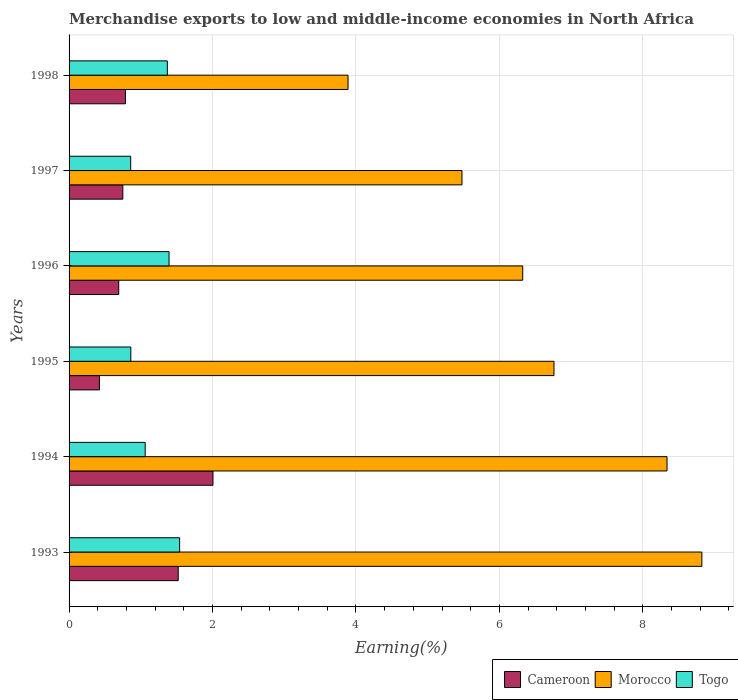How many different coloured bars are there?
Provide a succinct answer. 3. Are the number of bars on each tick of the Y-axis equal?
Your answer should be compact. Yes. How many bars are there on the 3rd tick from the bottom?
Offer a very short reply. 3. In how many cases, is the number of bars for a given year not equal to the number of legend labels?
Make the answer very short. 0. What is the percentage of amount earned from merchandise exports in Morocco in 1996?
Your answer should be very brief. 6.32. Across all years, what is the maximum percentage of amount earned from merchandise exports in Cameroon?
Your answer should be compact. 2.01. Across all years, what is the minimum percentage of amount earned from merchandise exports in Cameroon?
Offer a very short reply. 0.42. In which year was the percentage of amount earned from merchandise exports in Cameroon maximum?
Give a very brief answer. 1994. What is the total percentage of amount earned from merchandise exports in Togo in the graph?
Provide a short and direct response. 7.09. What is the difference between the percentage of amount earned from merchandise exports in Togo in 1993 and that in 1996?
Give a very brief answer. 0.15. What is the difference between the percentage of amount earned from merchandise exports in Morocco in 1997 and the percentage of amount earned from merchandise exports in Togo in 1998?
Provide a short and direct response. 4.11. What is the average percentage of amount earned from merchandise exports in Cameroon per year?
Your answer should be compact. 1.03. In the year 1995, what is the difference between the percentage of amount earned from merchandise exports in Togo and percentage of amount earned from merchandise exports in Cameroon?
Your response must be concise. 0.44. What is the ratio of the percentage of amount earned from merchandise exports in Togo in 1996 to that in 1997?
Provide a succinct answer. 1.62. What is the difference between the highest and the second highest percentage of amount earned from merchandise exports in Cameroon?
Make the answer very short. 0.48. What is the difference between the highest and the lowest percentage of amount earned from merchandise exports in Togo?
Make the answer very short. 0.68. What does the 3rd bar from the top in 1998 represents?
Offer a very short reply. Cameroon. What does the 3rd bar from the bottom in 1993 represents?
Your answer should be compact. Togo. What is the difference between two consecutive major ticks on the X-axis?
Ensure brevity in your answer.  2. Where does the legend appear in the graph?
Ensure brevity in your answer.  Bottom right. What is the title of the graph?
Your response must be concise. Merchandise exports to low and middle-income economies in North Africa. Does "India" appear as one of the legend labels in the graph?
Make the answer very short. No. What is the label or title of the X-axis?
Provide a short and direct response. Earning(%). What is the label or title of the Y-axis?
Your answer should be very brief. Years. What is the Earning(%) of Cameroon in 1993?
Give a very brief answer. 1.52. What is the Earning(%) in Morocco in 1993?
Your response must be concise. 8.82. What is the Earning(%) of Togo in 1993?
Provide a short and direct response. 1.54. What is the Earning(%) in Cameroon in 1994?
Give a very brief answer. 2.01. What is the Earning(%) of Morocco in 1994?
Offer a very short reply. 8.34. What is the Earning(%) of Togo in 1994?
Your answer should be very brief. 1.06. What is the Earning(%) in Cameroon in 1995?
Offer a terse response. 0.42. What is the Earning(%) in Morocco in 1995?
Offer a terse response. 6.76. What is the Earning(%) of Togo in 1995?
Make the answer very short. 0.86. What is the Earning(%) in Cameroon in 1996?
Give a very brief answer. 0.69. What is the Earning(%) of Morocco in 1996?
Provide a succinct answer. 6.32. What is the Earning(%) in Togo in 1996?
Give a very brief answer. 1.39. What is the Earning(%) of Cameroon in 1997?
Provide a short and direct response. 0.75. What is the Earning(%) of Morocco in 1997?
Provide a succinct answer. 5.48. What is the Earning(%) in Togo in 1997?
Provide a short and direct response. 0.86. What is the Earning(%) of Cameroon in 1998?
Ensure brevity in your answer.  0.79. What is the Earning(%) of Morocco in 1998?
Provide a short and direct response. 3.89. What is the Earning(%) of Togo in 1998?
Make the answer very short. 1.37. Across all years, what is the maximum Earning(%) of Cameroon?
Ensure brevity in your answer.  2.01. Across all years, what is the maximum Earning(%) in Morocco?
Your answer should be very brief. 8.82. Across all years, what is the maximum Earning(%) of Togo?
Provide a short and direct response. 1.54. Across all years, what is the minimum Earning(%) of Cameroon?
Give a very brief answer. 0.42. Across all years, what is the minimum Earning(%) of Morocco?
Ensure brevity in your answer.  3.89. Across all years, what is the minimum Earning(%) in Togo?
Provide a succinct answer. 0.86. What is the total Earning(%) in Cameroon in the graph?
Offer a terse response. 6.18. What is the total Earning(%) in Morocco in the graph?
Your answer should be very brief. 39.61. What is the total Earning(%) of Togo in the graph?
Give a very brief answer. 7.09. What is the difference between the Earning(%) of Cameroon in 1993 and that in 1994?
Ensure brevity in your answer.  -0.48. What is the difference between the Earning(%) in Morocco in 1993 and that in 1994?
Make the answer very short. 0.49. What is the difference between the Earning(%) in Togo in 1993 and that in 1994?
Provide a short and direct response. 0.48. What is the difference between the Earning(%) in Cameroon in 1993 and that in 1995?
Your response must be concise. 1.1. What is the difference between the Earning(%) of Morocco in 1993 and that in 1995?
Offer a very short reply. 2.06. What is the difference between the Earning(%) of Togo in 1993 and that in 1995?
Make the answer very short. 0.68. What is the difference between the Earning(%) in Cameroon in 1993 and that in 1996?
Ensure brevity in your answer.  0.83. What is the difference between the Earning(%) in Morocco in 1993 and that in 1996?
Make the answer very short. 2.5. What is the difference between the Earning(%) in Togo in 1993 and that in 1996?
Ensure brevity in your answer.  0.15. What is the difference between the Earning(%) of Cameroon in 1993 and that in 1997?
Make the answer very short. 0.77. What is the difference between the Earning(%) in Morocco in 1993 and that in 1997?
Make the answer very short. 3.34. What is the difference between the Earning(%) of Togo in 1993 and that in 1997?
Keep it short and to the point. 0.68. What is the difference between the Earning(%) of Cameroon in 1993 and that in 1998?
Offer a very short reply. 0.74. What is the difference between the Earning(%) of Morocco in 1993 and that in 1998?
Make the answer very short. 4.93. What is the difference between the Earning(%) of Togo in 1993 and that in 1998?
Your answer should be compact. 0.17. What is the difference between the Earning(%) in Cameroon in 1994 and that in 1995?
Make the answer very short. 1.58. What is the difference between the Earning(%) of Morocco in 1994 and that in 1995?
Ensure brevity in your answer.  1.58. What is the difference between the Earning(%) in Togo in 1994 and that in 1995?
Make the answer very short. 0.2. What is the difference between the Earning(%) of Cameroon in 1994 and that in 1996?
Your response must be concise. 1.31. What is the difference between the Earning(%) in Morocco in 1994 and that in 1996?
Your answer should be very brief. 2.01. What is the difference between the Earning(%) in Togo in 1994 and that in 1996?
Offer a terse response. -0.33. What is the difference between the Earning(%) of Cameroon in 1994 and that in 1997?
Offer a very short reply. 1.26. What is the difference between the Earning(%) of Morocco in 1994 and that in 1997?
Your response must be concise. 2.86. What is the difference between the Earning(%) of Togo in 1994 and that in 1997?
Give a very brief answer. 0.2. What is the difference between the Earning(%) in Cameroon in 1994 and that in 1998?
Provide a succinct answer. 1.22. What is the difference between the Earning(%) in Morocco in 1994 and that in 1998?
Provide a short and direct response. 4.45. What is the difference between the Earning(%) in Togo in 1994 and that in 1998?
Your answer should be compact. -0.31. What is the difference between the Earning(%) in Cameroon in 1995 and that in 1996?
Offer a very short reply. -0.27. What is the difference between the Earning(%) of Morocco in 1995 and that in 1996?
Ensure brevity in your answer.  0.44. What is the difference between the Earning(%) in Togo in 1995 and that in 1996?
Offer a terse response. -0.53. What is the difference between the Earning(%) in Cameroon in 1995 and that in 1997?
Your answer should be compact. -0.33. What is the difference between the Earning(%) in Morocco in 1995 and that in 1997?
Provide a short and direct response. 1.28. What is the difference between the Earning(%) of Togo in 1995 and that in 1997?
Your answer should be compact. 0. What is the difference between the Earning(%) in Cameroon in 1995 and that in 1998?
Keep it short and to the point. -0.36. What is the difference between the Earning(%) of Morocco in 1995 and that in 1998?
Keep it short and to the point. 2.87. What is the difference between the Earning(%) of Togo in 1995 and that in 1998?
Offer a very short reply. -0.51. What is the difference between the Earning(%) of Cameroon in 1996 and that in 1997?
Provide a succinct answer. -0.06. What is the difference between the Earning(%) of Morocco in 1996 and that in 1997?
Give a very brief answer. 0.85. What is the difference between the Earning(%) of Togo in 1996 and that in 1997?
Your response must be concise. 0.53. What is the difference between the Earning(%) in Cameroon in 1996 and that in 1998?
Your answer should be very brief. -0.09. What is the difference between the Earning(%) of Morocco in 1996 and that in 1998?
Provide a succinct answer. 2.44. What is the difference between the Earning(%) in Togo in 1996 and that in 1998?
Provide a succinct answer. 0.02. What is the difference between the Earning(%) of Cameroon in 1997 and that in 1998?
Provide a succinct answer. -0.04. What is the difference between the Earning(%) in Morocco in 1997 and that in 1998?
Provide a short and direct response. 1.59. What is the difference between the Earning(%) of Togo in 1997 and that in 1998?
Your answer should be compact. -0.51. What is the difference between the Earning(%) of Cameroon in 1993 and the Earning(%) of Morocco in 1994?
Provide a succinct answer. -6.81. What is the difference between the Earning(%) of Cameroon in 1993 and the Earning(%) of Togo in 1994?
Make the answer very short. 0.46. What is the difference between the Earning(%) in Morocco in 1993 and the Earning(%) in Togo in 1994?
Provide a short and direct response. 7.76. What is the difference between the Earning(%) in Cameroon in 1993 and the Earning(%) in Morocco in 1995?
Provide a succinct answer. -5.24. What is the difference between the Earning(%) of Cameroon in 1993 and the Earning(%) of Togo in 1995?
Provide a short and direct response. 0.66. What is the difference between the Earning(%) in Morocco in 1993 and the Earning(%) in Togo in 1995?
Your answer should be compact. 7.96. What is the difference between the Earning(%) of Cameroon in 1993 and the Earning(%) of Morocco in 1996?
Make the answer very short. -4.8. What is the difference between the Earning(%) of Cameroon in 1993 and the Earning(%) of Togo in 1996?
Give a very brief answer. 0.13. What is the difference between the Earning(%) in Morocco in 1993 and the Earning(%) in Togo in 1996?
Provide a succinct answer. 7.43. What is the difference between the Earning(%) in Cameroon in 1993 and the Earning(%) in Morocco in 1997?
Provide a succinct answer. -3.96. What is the difference between the Earning(%) of Cameroon in 1993 and the Earning(%) of Togo in 1997?
Your answer should be very brief. 0.66. What is the difference between the Earning(%) in Morocco in 1993 and the Earning(%) in Togo in 1997?
Your response must be concise. 7.96. What is the difference between the Earning(%) of Cameroon in 1993 and the Earning(%) of Morocco in 1998?
Give a very brief answer. -2.37. What is the difference between the Earning(%) in Cameroon in 1993 and the Earning(%) in Togo in 1998?
Your response must be concise. 0.15. What is the difference between the Earning(%) in Morocco in 1993 and the Earning(%) in Togo in 1998?
Your answer should be very brief. 7.45. What is the difference between the Earning(%) of Cameroon in 1994 and the Earning(%) of Morocco in 1995?
Provide a short and direct response. -4.75. What is the difference between the Earning(%) of Cameroon in 1994 and the Earning(%) of Togo in 1995?
Make the answer very short. 1.15. What is the difference between the Earning(%) in Morocco in 1994 and the Earning(%) in Togo in 1995?
Ensure brevity in your answer.  7.48. What is the difference between the Earning(%) of Cameroon in 1994 and the Earning(%) of Morocco in 1996?
Provide a succinct answer. -4.32. What is the difference between the Earning(%) of Cameroon in 1994 and the Earning(%) of Togo in 1996?
Offer a very short reply. 0.61. What is the difference between the Earning(%) of Morocco in 1994 and the Earning(%) of Togo in 1996?
Keep it short and to the point. 6.94. What is the difference between the Earning(%) in Cameroon in 1994 and the Earning(%) in Morocco in 1997?
Ensure brevity in your answer.  -3.47. What is the difference between the Earning(%) of Cameroon in 1994 and the Earning(%) of Togo in 1997?
Your answer should be very brief. 1.15. What is the difference between the Earning(%) of Morocco in 1994 and the Earning(%) of Togo in 1997?
Make the answer very short. 7.48. What is the difference between the Earning(%) of Cameroon in 1994 and the Earning(%) of Morocco in 1998?
Provide a short and direct response. -1.88. What is the difference between the Earning(%) in Cameroon in 1994 and the Earning(%) in Togo in 1998?
Your response must be concise. 0.64. What is the difference between the Earning(%) of Morocco in 1994 and the Earning(%) of Togo in 1998?
Give a very brief answer. 6.97. What is the difference between the Earning(%) of Cameroon in 1995 and the Earning(%) of Morocco in 1996?
Your response must be concise. -5.9. What is the difference between the Earning(%) of Cameroon in 1995 and the Earning(%) of Togo in 1996?
Your response must be concise. -0.97. What is the difference between the Earning(%) of Morocco in 1995 and the Earning(%) of Togo in 1996?
Keep it short and to the point. 5.37. What is the difference between the Earning(%) in Cameroon in 1995 and the Earning(%) in Morocco in 1997?
Offer a terse response. -5.05. What is the difference between the Earning(%) in Cameroon in 1995 and the Earning(%) in Togo in 1997?
Your answer should be very brief. -0.44. What is the difference between the Earning(%) in Morocco in 1995 and the Earning(%) in Togo in 1997?
Your response must be concise. 5.9. What is the difference between the Earning(%) of Cameroon in 1995 and the Earning(%) of Morocco in 1998?
Provide a succinct answer. -3.47. What is the difference between the Earning(%) in Cameroon in 1995 and the Earning(%) in Togo in 1998?
Provide a short and direct response. -0.95. What is the difference between the Earning(%) in Morocco in 1995 and the Earning(%) in Togo in 1998?
Provide a succinct answer. 5.39. What is the difference between the Earning(%) in Cameroon in 1996 and the Earning(%) in Morocco in 1997?
Offer a terse response. -4.79. What is the difference between the Earning(%) of Cameroon in 1996 and the Earning(%) of Togo in 1997?
Offer a terse response. -0.17. What is the difference between the Earning(%) of Morocco in 1996 and the Earning(%) of Togo in 1997?
Provide a short and direct response. 5.47. What is the difference between the Earning(%) of Cameroon in 1996 and the Earning(%) of Morocco in 1998?
Make the answer very short. -3.2. What is the difference between the Earning(%) of Cameroon in 1996 and the Earning(%) of Togo in 1998?
Provide a succinct answer. -0.68. What is the difference between the Earning(%) in Morocco in 1996 and the Earning(%) in Togo in 1998?
Keep it short and to the point. 4.95. What is the difference between the Earning(%) in Cameroon in 1997 and the Earning(%) in Morocco in 1998?
Your answer should be compact. -3.14. What is the difference between the Earning(%) of Cameroon in 1997 and the Earning(%) of Togo in 1998?
Offer a terse response. -0.62. What is the difference between the Earning(%) of Morocco in 1997 and the Earning(%) of Togo in 1998?
Your answer should be very brief. 4.11. What is the average Earning(%) of Cameroon per year?
Offer a terse response. 1.03. What is the average Earning(%) in Morocco per year?
Your answer should be very brief. 6.6. What is the average Earning(%) of Togo per year?
Provide a succinct answer. 1.18. In the year 1993, what is the difference between the Earning(%) of Cameroon and Earning(%) of Morocco?
Your answer should be very brief. -7.3. In the year 1993, what is the difference between the Earning(%) in Cameroon and Earning(%) in Togo?
Offer a very short reply. -0.02. In the year 1993, what is the difference between the Earning(%) in Morocco and Earning(%) in Togo?
Offer a terse response. 7.28. In the year 1994, what is the difference between the Earning(%) in Cameroon and Earning(%) in Morocco?
Provide a short and direct response. -6.33. In the year 1994, what is the difference between the Earning(%) of Cameroon and Earning(%) of Togo?
Provide a succinct answer. 0.94. In the year 1994, what is the difference between the Earning(%) in Morocco and Earning(%) in Togo?
Make the answer very short. 7.27. In the year 1995, what is the difference between the Earning(%) of Cameroon and Earning(%) of Morocco?
Your answer should be very brief. -6.34. In the year 1995, what is the difference between the Earning(%) in Cameroon and Earning(%) in Togo?
Make the answer very short. -0.44. In the year 1995, what is the difference between the Earning(%) of Morocco and Earning(%) of Togo?
Keep it short and to the point. 5.9. In the year 1996, what is the difference between the Earning(%) of Cameroon and Earning(%) of Morocco?
Keep it short and to the point. -5.63. In the year 1996, what is the difference between the Earning(%) in Cameroon and Earning(%) in Togo?
Provide a succinct answer. -0.7. In the year 1996, what is the difference between the Earning(%) of Morocco and Earning(%) of Togo?
Make the answer very short. 4.93. In the year 1997, what is the difference between the Earning(%) in Cameroon and Earning(%) in Morocco?
Keep it short and to the point. -4.73. In the year 1997, what is the difference between the Earning(%) in Cameroon and Earning(%) in Togo?
Your answer should be compact. -0.11. In the year 1997, what is the difference between the Earning(%) of Morocco and Earning(%) of Togo?
Offer a very short reply. 4.62. In the year 1998, what is the difference between the Earning(%) of Cameroon and Earning(%) of Morocco?
Make the answer very short. -3.1. In the year 1998, what is the difference between the Earning(%) of Cameroon and Earning(%) of Togo?
Ensure brevity in your answer.  -0.58. In the year 1998, what is the difference between the Earning(%) in Morocco and Earning(%) in Togo?
Your answer should be very brief. 2.52. What is the ratio of the Earning(%) of Cameroon in 1993 to that in 1994?
Keep it short and to the point. 0.76. What is the ratio of the Earning(%) in Morocco in 1993 to that in 1994?
Keep it short and to the point. 1.06. What is the ratio of the Earning(%) in Togo in 1993 to that in 1994?
Offer a terse response. 1.45. What is the ratio of the Earning(%) of Cameroon in 1993 to that in 1995?
Ensure brevity in your answer.  3.6. What is the ratio of the Earning(%) of Morocco in 1993 to that in 1995?
Offer a terse response. 1.3. What is the ratio of the Earning(%) of Togo in 1993 to that in 1995?
Keep it short and to the point. 1.79. What is the ratio of the Earning(%) of Cameroon in 1993 to that in 1996?
Offer a terse response. 2.2. What is the ratio of the Earning(%) of Morocco in 1993 to that in 1996?
Provide a succinct answer. 1.39. What is the ratio of the Earning(%) in Togo in 1993 to that in 1996?
Provide a succinct answer. 1.11. What is the ratio of the Earning(%) in Cameroon in 1993 to that in 1997?
Offer a terse response. 2.03. What is the ratio of the Earning(%) of Morocco in 1993 to that in 1997?
Your answer should be very brief. 1.61. What is the ratio of the Earning(%) of Togo in 1993 to that in 1997?
Keep it short and to the point. 1.79. What is the ratio of the Earning(%) in Cameroon in 1993 to that in 1998?
Your response must be concise. 1.94. What is the ratio of the Earning(%) of Morocco in 1993 to that in 1998?
Offer a very short reply. 2.27. What is the ratio of the Earning(%) in Togo in 1993 to that in 1998?
Your response must be concise. 1.13. What is the ratio of the Earning(%) of Cameroon in 1994 to that in 1995?
Offer a very short reply. 4.74. What is the ratio of the Earning(%) in Morocco in 1994 to that in 1995?
Offer a very short reply. 1.23. What is the ratio of the Earning(%) of Togo in 1994 to that in 1995?
Provide a short and direct response. 1.23. What is the ratio of the Earning(%) of Cameroon in 1994 to that in 1996?
Provide a succinct answer. 2.9. What is the ratio of the Earning(%) in Morocco in 1994 to that in 1996?
Make the answer very short. 1.32. What is the ratio of the Earning(%) of Togo in 1994 to that in 1996?
Give a very brief answer. 0.76. What is the ratio of the Earning(%) of Cameroon in 1994 to that in 1997?
Your response must be concise. 2.68. What is the ratio of the Earning(%) of Morocco in 1994 to that in 1997?
Ensure brevity in your answer.  1.52. What is the ratio of the Earning(%) in Togo in 1994 to that in 1997?
Ensure brevity in your answer.  1.24. What is the ratio of the Earning(%) in Cameroon in 1994 to that in 1998?
Your answer should be compact. 2.55. What is the ratio of the Earning(%) of Morocco in 1994 to that in 1998?
Your answer should be very brief. 2.14. What is the ratio of the Earning(%) in Togo in 1994 to that in 1998?
Offer a very short reply. 0.77. What is the ratio of the Earning(%) in Cameroon in 1995 to that in 1996?
Provide a succinct answer. 0.61. What is the ratio of the Earning(%) of Morocco in 1995 to that in 1996?
Provide a succinct answer. 1.07. What is the ratio of the Earning(%) in Togo in 1995 to that in 1996?
Give a very brief answer. 0.62. What is the ratio of the Earning(%) of Cameroon in 1995 to that in 1997?
Your answer should be compact. 0.56. What is the ratio of the Earning(%) in Morocco in 1995 to that in 1997?
Provide a short and direct response. 1.23. What is the ratio of the Earning(%) of Cameroon in 1995 to that in 1998?
Your answer should be compact. 0.54. What is the ratio of the Earning(%) of Morocco in 1995 to that in 1998?
Keep it short and to the point. 1.74. What is the ratio of the Earning(%) of Togo in 1995 to that in 1998?
Provide a succinct answer. 0.63. What is the ratio of the Earning(%) in Cameroon in 1996 to that in 1997?
Your response must be concise. 0.92. What is the ratio of the Earning(%) of Morocco in 1996 to that in 1997?
Provide a short and direct response. 1.15. What is the ratio of the Earning(%) in Togo in 1996 to that in 1997?
Your answer should be compact. 1.62. What is the ratio of the Earning(%) in Cameroon in 1996 to that in 1998?
Your answer should be very brief. 0.88. What is the ratio of the Earning(%) of Morocco in 1996 to that in 1998?
Provide a short and direct response. 1.63. What is the ratio of the Earning(%) of Togo in 1996 to that in 1998?
Provide a succinct answer. 1.02. What is the ratio of the Earning(%) in Cameroon in 1997 to that in 1998?
Provide a succinct answer. 0.95. What is the ratio of the Earning(%) of Morocco in 1997 to that in 1998?
Your answer should be compact. 1.41. What is the ratio of the Earning(%) of Togo in 1997 to that in 1998?
Your answer should be compact. 0.63. What is the difference between the highest and the second highest Earning(%) of Cameroon?
Provide a succinct answer. 0.48. What is the difference between the highest and the second highest Earning(%) of Morocco?
Offer a very short reply. 0.49. What is the difference between the highest and the second highest Earning(%) of Togo?
Your answer should be very brief. 0.15. What is the difference between the highest and the lowest Earning(%) of Cameroon?
Your answer should be very brief. 1.58. What is the difference between the highest and the lowest Earning(%) of Morocco?
Offer a very short reply. 4.93. What is the difference between the highest and the lowest Earning(%) in Togo?
Ensure brevity in your answer.  0.68. 